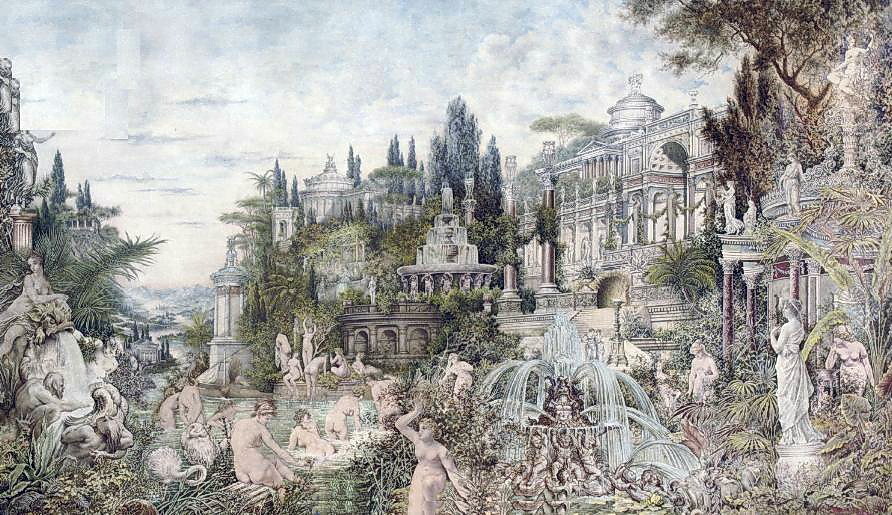Describe the following image. The image depicts an elaborate and fantastical landscape, featuring a grand palace at its heart, surrounded by a lush, meticulously designed garden. The architectural style of the palace is indicative of the Rococo period, famed for its ornate and decorative details, such as sculptural embellishments and intricate facades.

The gardens are a tableau of classical beauty, adorned with statues reminiscent of Greek and Roman antiquity, dynamic water fountains, and a wide variety of plants that add a vivid palette of greens, blues, and other pastel hues, enhancing the scene’s ethereal quality. This imagery might suggest the setting of a mythological story, inviting viewers to ponder the narratives that could unfold in such an environment. Overall, this image offers a rich tapestry of artistic elements that are both a feast for the eyes and a spark for the imagination. 